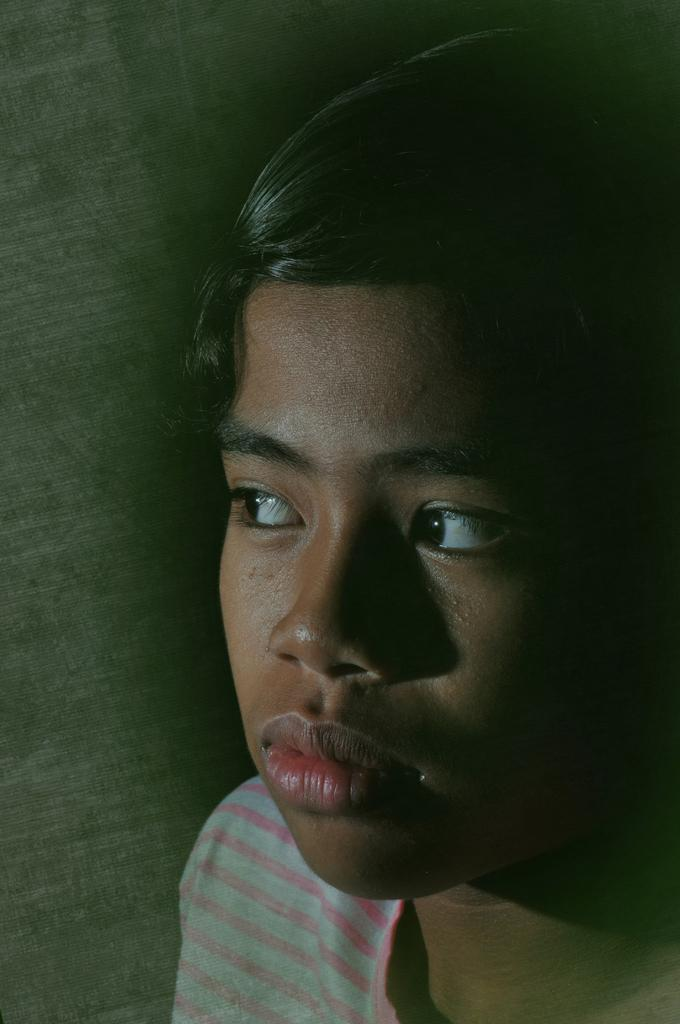What is the main subject of the image? There is a person in the image. What is the person wearing in the image? The person is wearing a dress in the image. What channel is the person watching on the television in the image? There is no television present in the image, so it is not possible to determine what channel the person might be watching. 